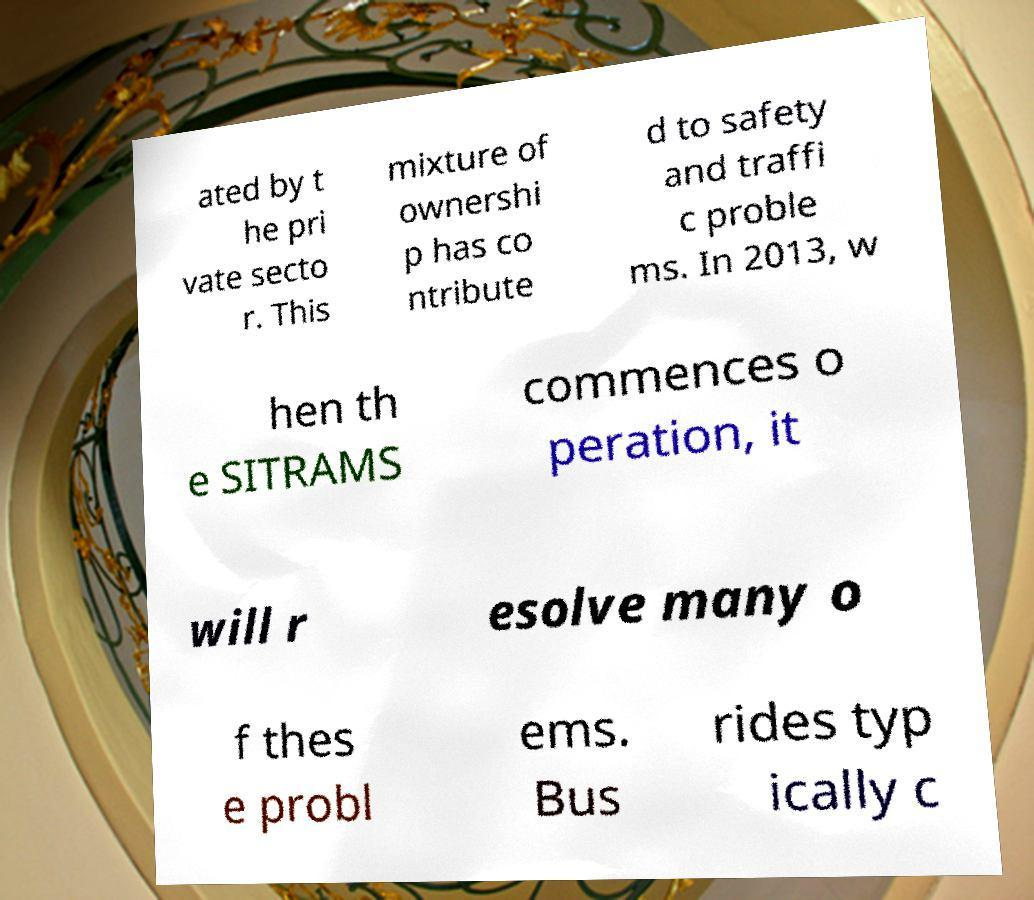Can you accurately transcribe the text from the provided image for me? ated by t he pri vate secto r. This mixture of ownershi p has co ntribute d to safety and traffi c proble ms. In 2013, w hen th e SITRAMS commences o peration, it will r esolve many o f thes e probl ems. Bus rides typ ically c 